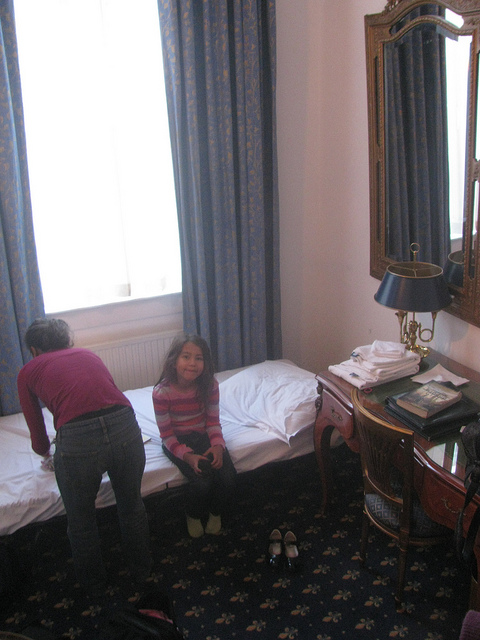How many people in the room? 2 